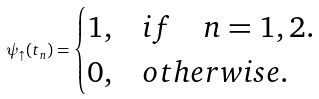<formula> <loc_0><loc_0><loc_500><loc_500>\psi _ { \uparrow } ( t _ { n } ) = \begin{cases} 1 , & i f \quad n = 1 , 2 . \\ 0 , & o t h e r w i s e . \end{cases}</formula> 